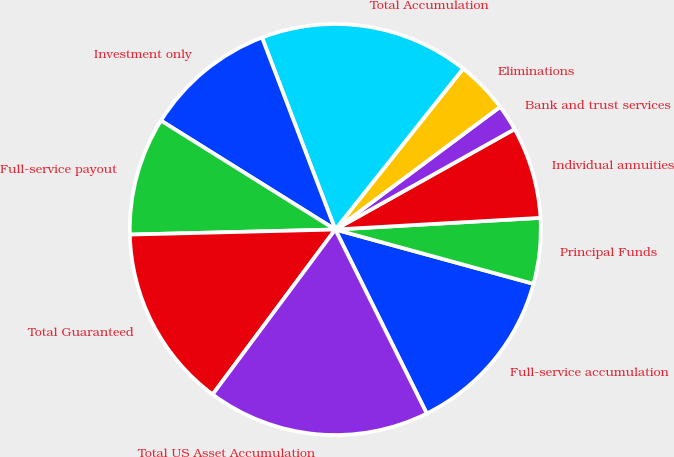Convert chart. <chart><loc_0><loc_0><loc_500><loc_500><pie_chart><fcel>Full-service accumulation<fcel>Principal Funds<fcel>Individual annuities<fcel>Bank and trust services<fcel>Eliminations<fcel>Total Accumulation<fcel>Investment only<fcel>Full-service payout<fcel>Total Guaranteed<fcel>Total US Asset Accumulation<nl><fcel>13.4%<fcel>5.16%<fcel>7.22%<fcel>2.06%<fcel>4.13%<fcel>16.49%<fcel>10.31%<fcel>9.28%<fcel>14.43%<fcel>17.52%<nl></chart> 